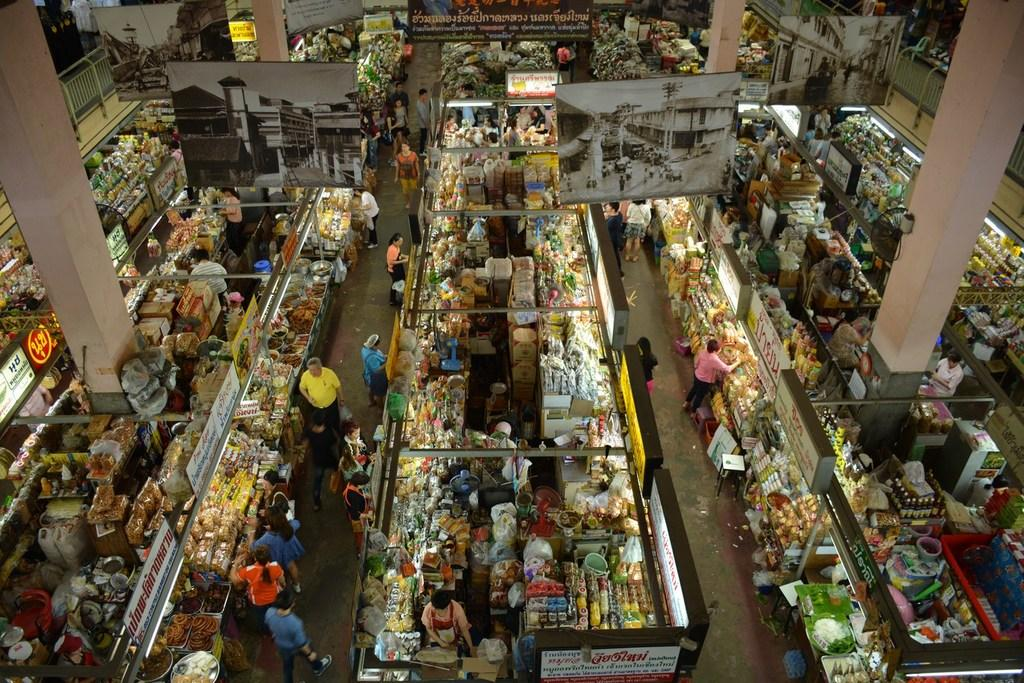<image>
Give a short and clear explanation of the subsequent image. Overview of a supermarket showing many people shopping and some Thai words. 